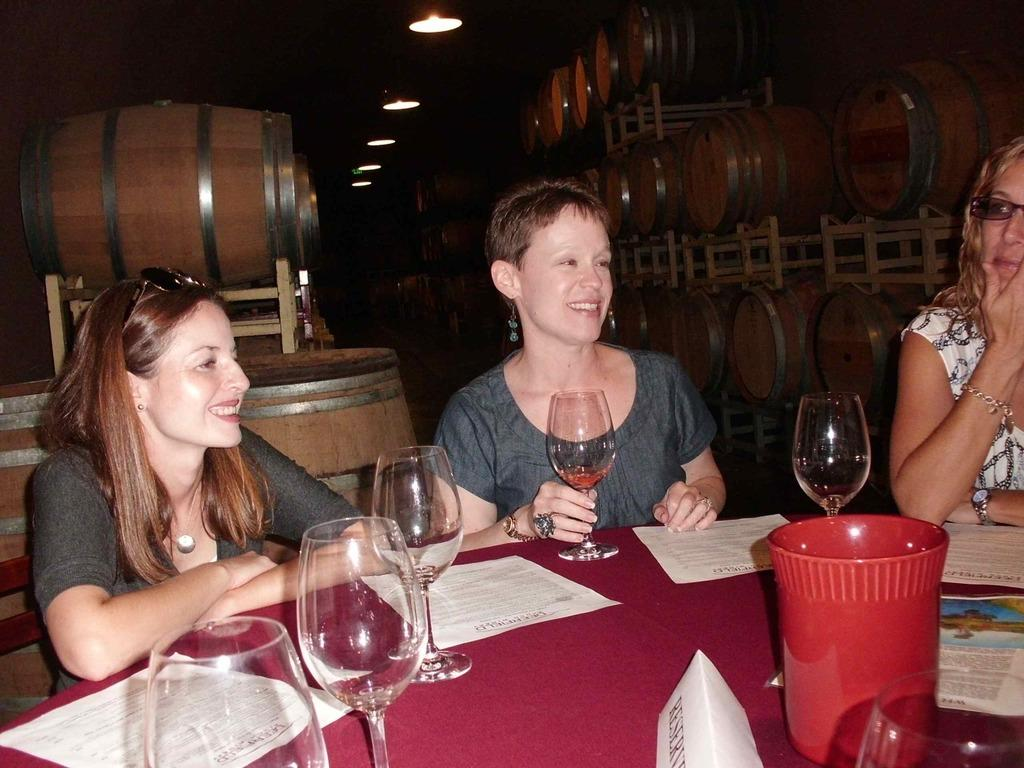How many people are in the image? There are three people in the image. What are the people doing in the image? The people are sitting on chairs. What is present on the table in the image? There are glasses, papers, and posters on the table. What type of pot is being used as a guide for the discovery in the image? There is no pot, guide, or discovery present in the image. 